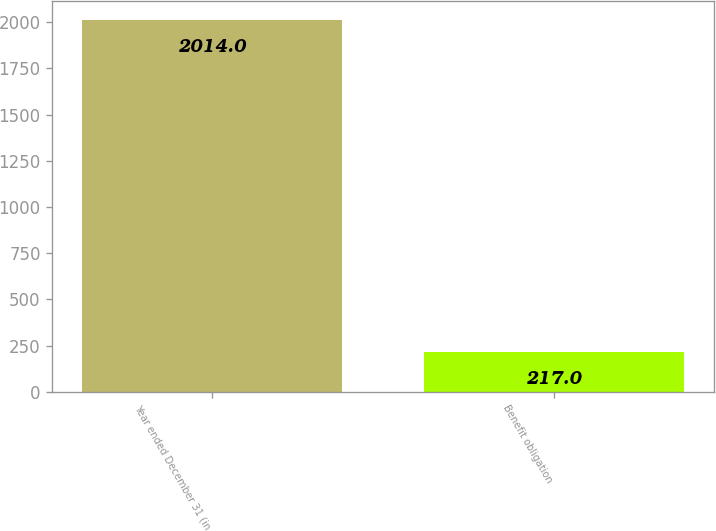Convert chart to OTSL. <chart><loc_0><loc_0><loc_500><loc_500><bar_chart><fcel>Year ended December 31 (in<fcel>Benefit obligation<nl><fcel>2014<fcel>217<nl></chart> 